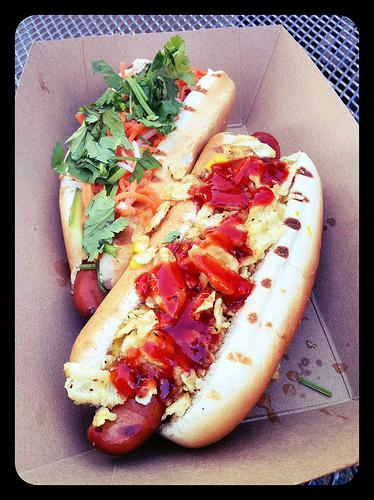Question: how are the hot dogs served?
Choices:
A. In BBQ sauce.
B. On buns.
C. On a stick.
D. In beans.
Answer with the letter. Answer: B Question: what food is this?
Choices:
A. Hamburgers.
B. Pizza.
C. Fried chicken.
D. Hot dogs.
Answer with the letter. Answer: D Question: what pattern is on the table cloth?
Choices:
A. Floral.
B. Stripes.
C. Chevron.
D. Checks.
Answer with the letter. Answer: D Question: where are the hot dogs sitting?
Choices:
A. On a grill.
B. On a table.
C. On a napkin.
D. On a frying pan.
Answer with the letter. Answer: B Question: how were the hot dogs cooked?
Choices:
A. Baked.
B. Fried.
C. Grilled.
D. In water.
Answer with the letter. Answer: C Question: what are the green leaves on the hot dogs?
Choices:
A. Grass.
B. Bay leaves.
C. Marijuana.
D. Cilantro.
Answer with the letter. Answer: D 